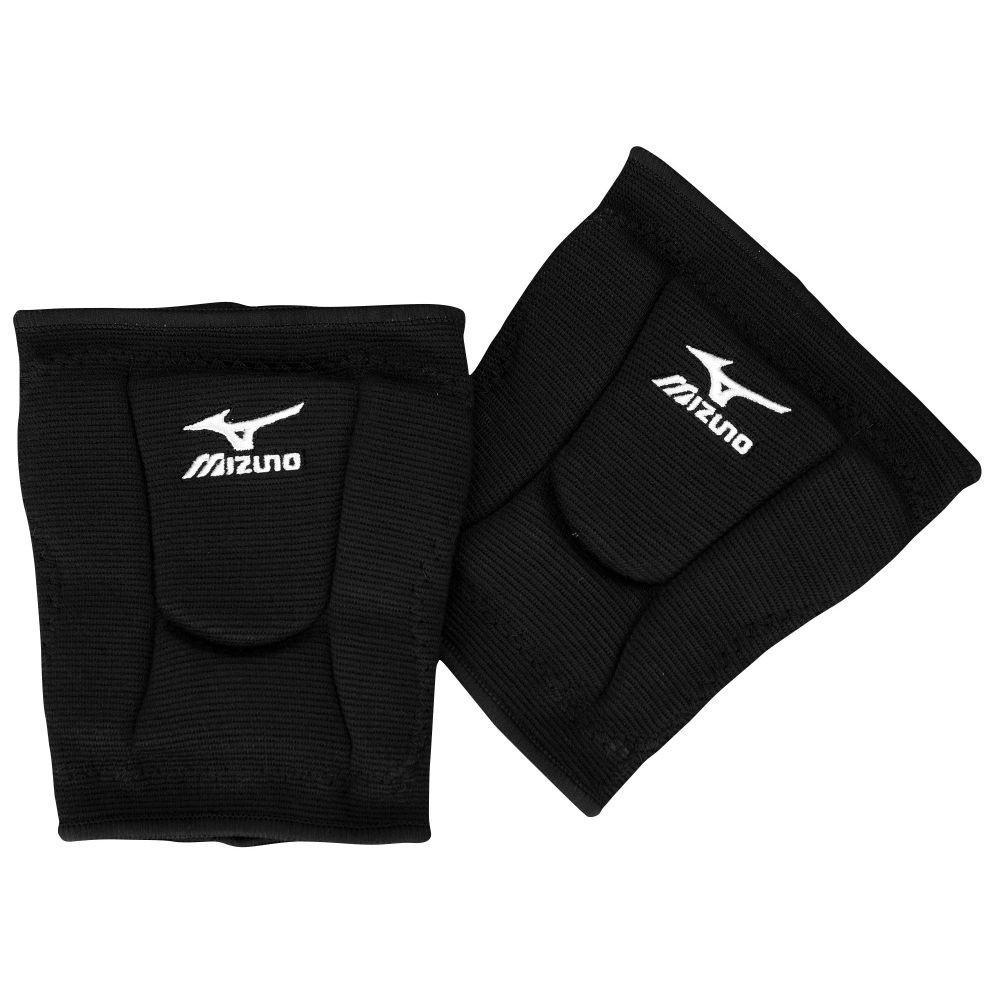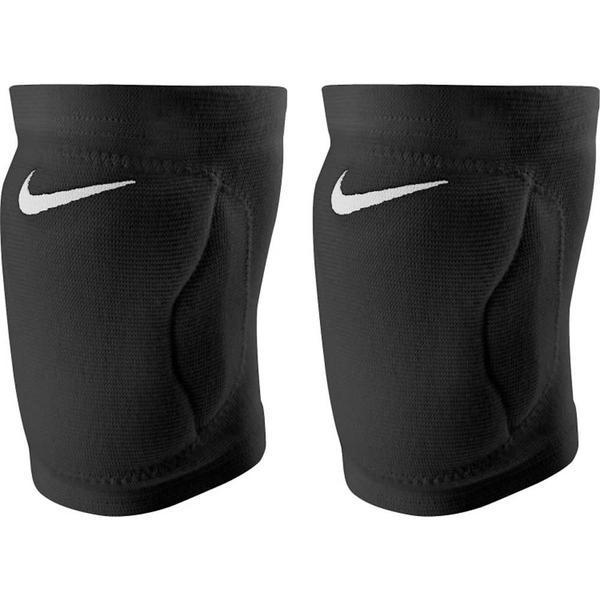The first image is the image on the left, the second image is the image on the right. For the images displayed, is the sentence "One image shows a black knee pad with a white logo and like a white knee pad with a black logo." factually correct? Answer yes or no. No. 